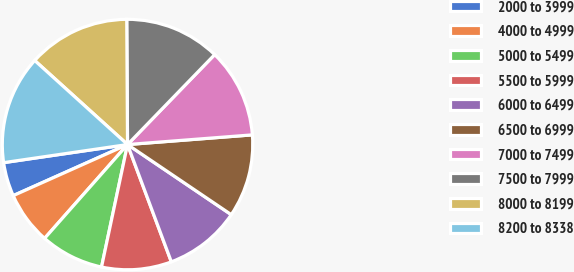Convert chart. <chart><loc_0><loc_0><loc_500><loc_500><pie_chart><fcel>2000 to 3999<fcel>4000 to 4999<fcel>5000 to 5499<fcel>5500 to 5999<fcel>6000 to 6499<fcel>6500 to 6999<fcel>7000 to 7499<fcel>7500 to 7999<fcel>8000 to 8199<fcel>8200 to 8338<nl><fcel>4.38%<fcel>6.79%<fcel>8.19%<fcel>9.02%<fcel>9.85%<fcel>10.69%<fcel>11.52%<fcel>12.35%<fcel>13.19%<fcel>14.02%<nl></chart> 